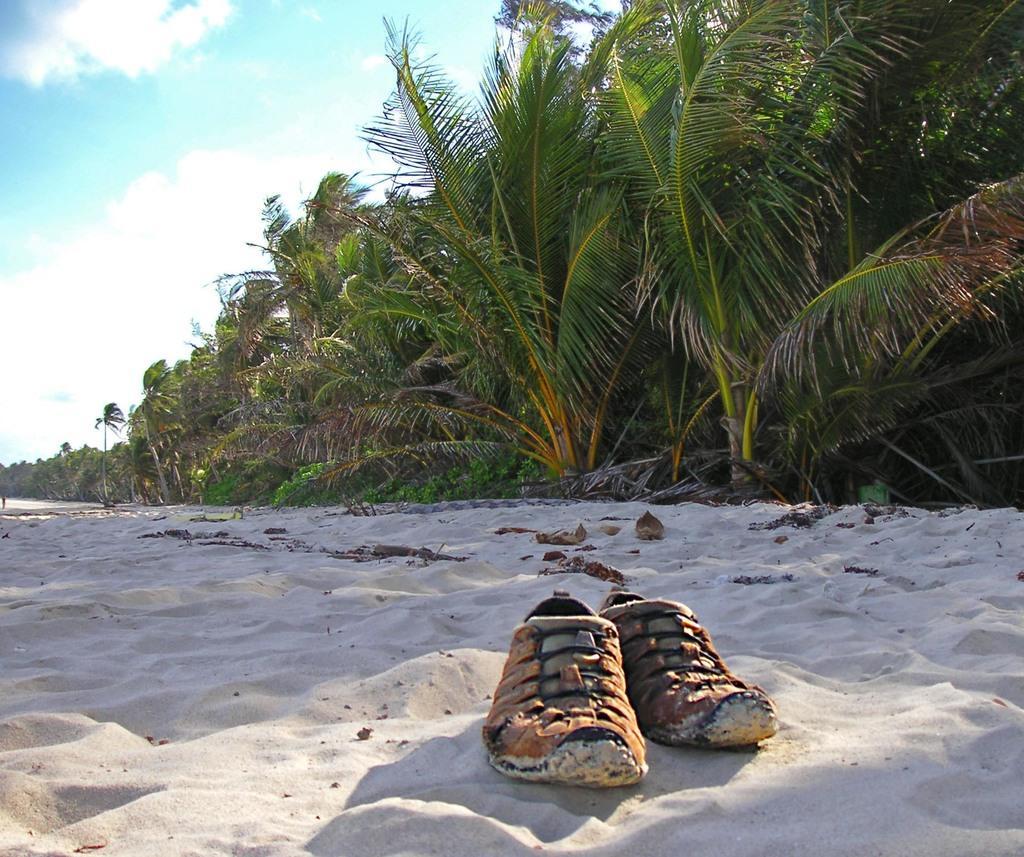Describe this image in one or two sentences. In this image we can see shoes on the sand. In the back there are trees. In the background there is sky with clouds. 